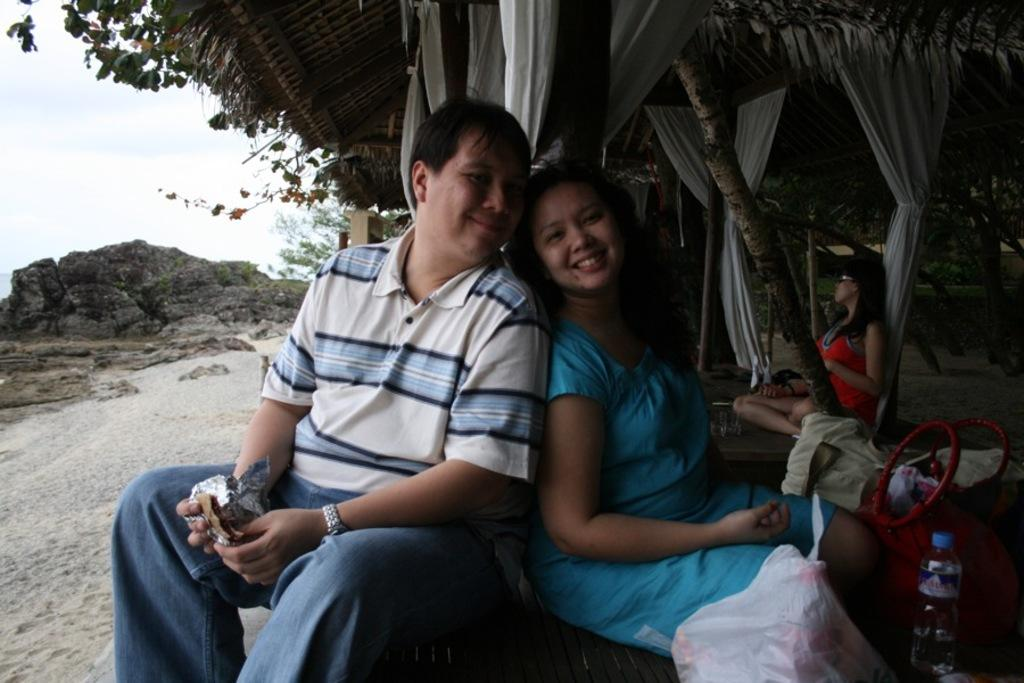Who are the two people in the image? There is a man and a woman in the image. Where are the man and woman sitting in the image? They are sitting under a tent. Are there any other people in the image? Yes, there are other people sitting behind the man. What can be seen in the background of the image? Rocks are visible on the seashore. What type of mouth does the farmer have in the image? There is no farmer present in the image, and therefore no mouth to describe. 